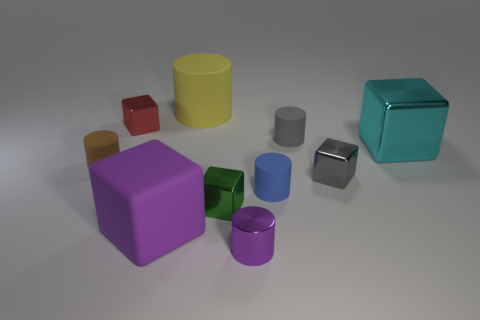Subtract all tiny red cubes. How many cubes are left? 4 Subtract all gray cylinders. How many cylinders are left? 4 Subtract 3 cylinders. How many cylinders are left? 2 Subtract all purple cylinders. Subtract all brown spheres. How many cylinders are left? 4 Add 1 big purple blocks. How many big purple blocks exist? 2 Subtract 0 yellow balls. How many objects are left? 10 Subtract all green objects. Subtract all tiny green metallic objects. How many objects are left? 8 Add 4 small purple cylinders. How many small purple cylinders are left? 5 